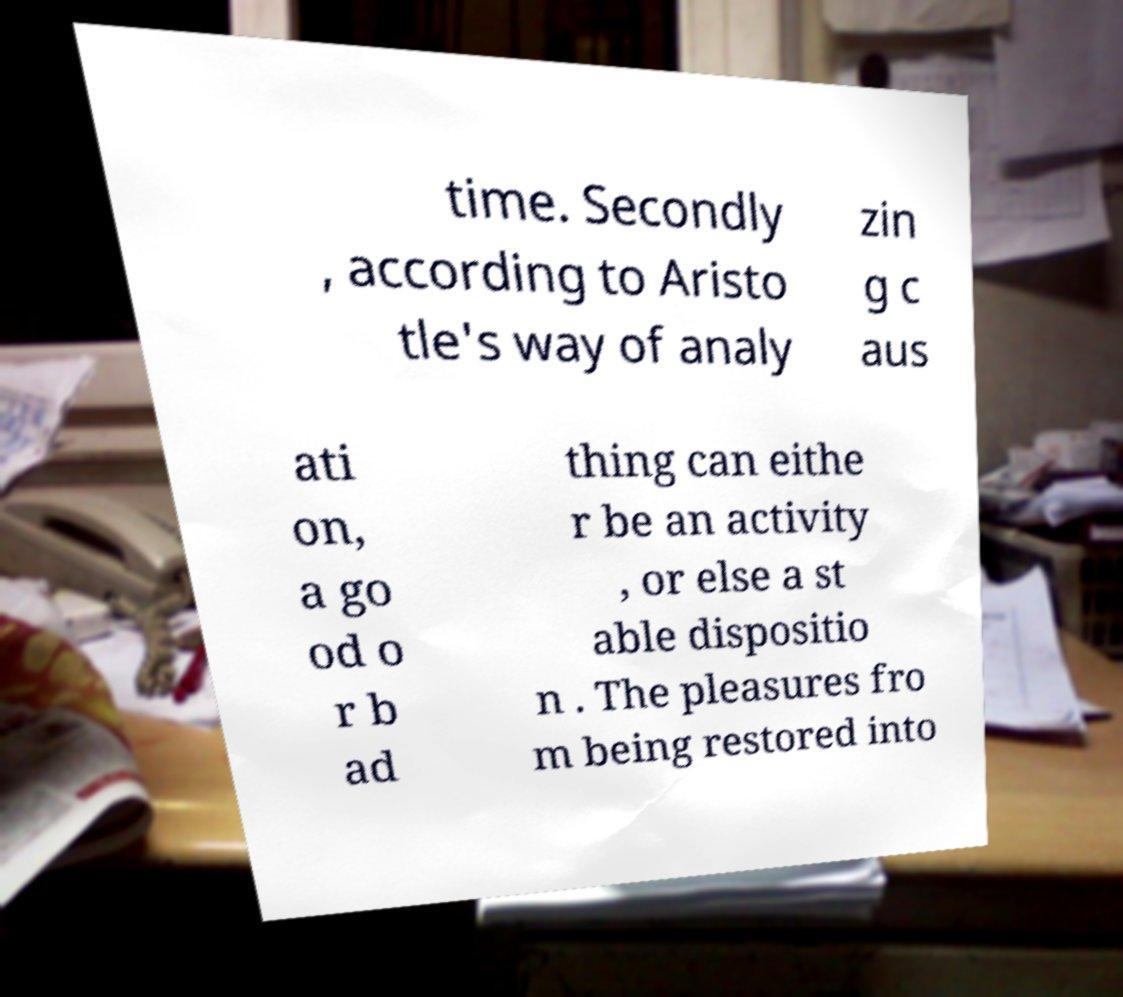Could you extract and type out the text from this image? time. Secondly , according to Aristo tle's way of analy zin g c aus ati on, a go od o r b ad thing can eithe r be an activity , or else a st able dispositio n . The pleasures fro m being restored into 